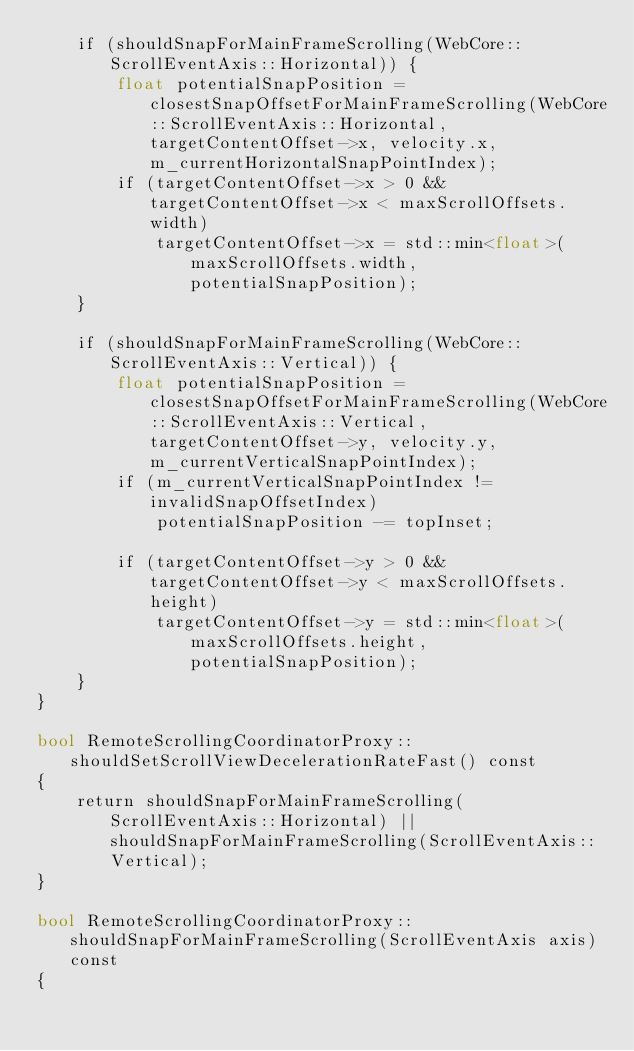Convert code to text. <code><loc_0><loc_0><loc_500><loc_500><_ObjectiveC_>    if (shouldSnapForMainFrameScrolling(WebCore::ScrollEventAxis::Horizontal)) {
        float potentialSnapPosition = closestSnapOffsetForMainFrameScrolling(WebCore::ScrollEventAxis::Horizontal, targetContentOffset->x, velocity.x, m_currentHorizontalSnapPointIndex);
        if (targetContentOffset->x > 0 && targetContentOffset->x < maxScrollOffsets.width)
            targetContentOffset->x = std::min<float>(maxScrollOffsets.width, potentialSnapPosition);
    }

    if (shouldSnapForMainFrameScrolling(WebCore::ScrollEventAxis::Vertical)) {
        float potentialSnapPosition = closestSnapOffsetForMainFrameScrolling(WebCore::ScrollEventAxis::Vertical, targetContentOffset->y, velocity.y, m_currentVerticalSnapPointIndex);
        if (m_currentVerticalSnapPointIndex != invalidSnapOffsetIndex)
            potentialSnapPosition -= topInset;

        if (targetContentOffset->y > 0 && targetContentOffset->y < maxScrollOffsets.height)
            targetContentOffset->y = std::min<float>(maxScrollOffsets.height, potentialSnapPosition);
    }
}

bool RemoteScrollingCoordinatorProxy::shouldSetScrollViewDecelerationRateFast() const
{
    return shouldSnapForMainFrameScrolling(ScrollEventAxis::Horizontal) || shouldSnapForMainFrameScrolling(ScrollEventAxis::Vertical);
}

bool RemoteScrollingCoordinatorProxy::shouldSnapForMainFrameScrolling(ScrollEventAxis axis) const
{</code> 